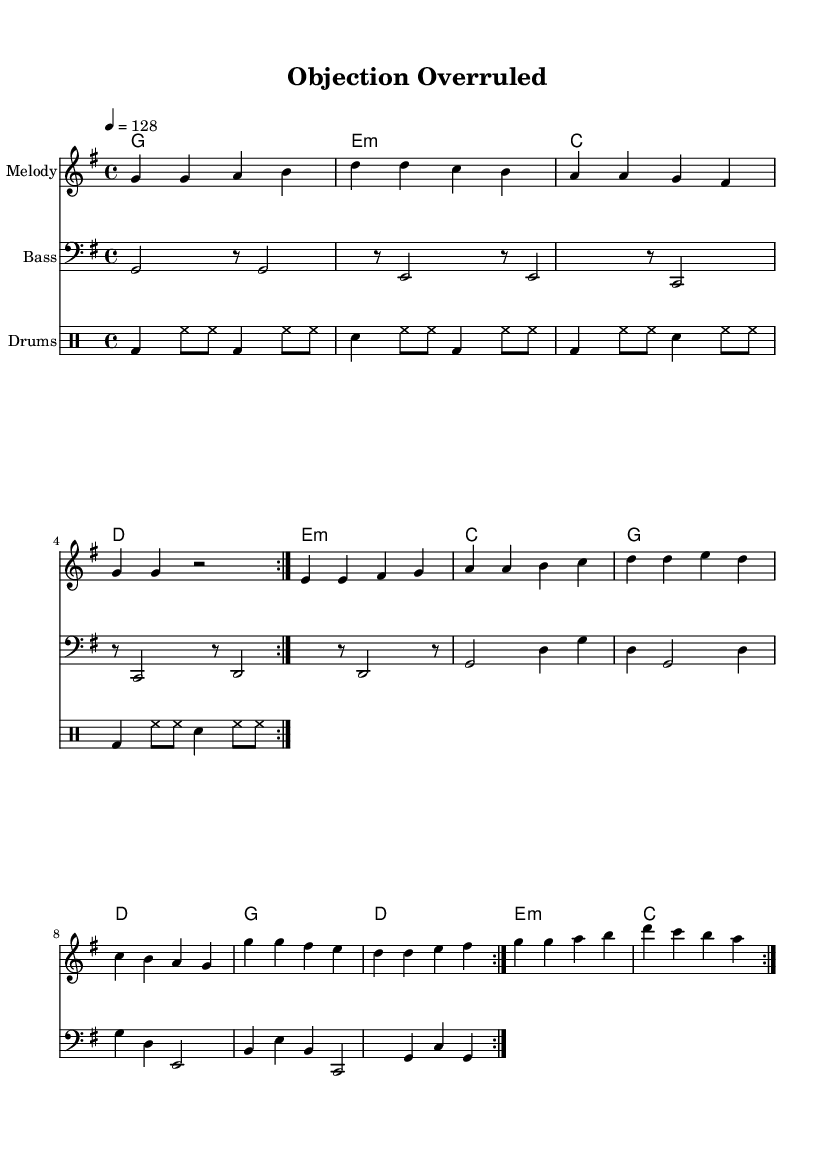What is the key signature of this music? The key signature indicated in the score is G major, which has one sharp (F#).
Answer: G major What is the time signature of the piece? The time signature shown in the score is 4/4, which means there are four beats per measure and the quarter note gets one beat.
Answer: 4/4 What is the tempo marking given in the score? The tempo marking specified is "4 = 128," indicating the quarter note should be played at 128 beats per minute.
Answer: 128 How many times is the main melody repeated? The main melody section is repeated twice, as indicated by the "repeat volta" notation at the beginning of the melody.
Answer: 2 What type of instrument is indicated for the melody part? The instrument for the melody part is described as "Melody" in the staff notation, indicating a vocal or lead instrument role typical in K-Pop.
Answer: Melody What is the structure of the harmonies section? The harmonies section follows a chord progression with specific chord names: g, e minor, c, and d, which are common in K-Pop compositions.
Answer: g, e minor, c, d Identify the rhythmic pattern in the drum part. The drum part uses a combination of bass drum (bd), snare drum (sn), and hi-hats (hh) in a repeating rhythmic pattern, creating an upbeat feel typical of K-Pop tracks.
Answer: bass and snare pattern 